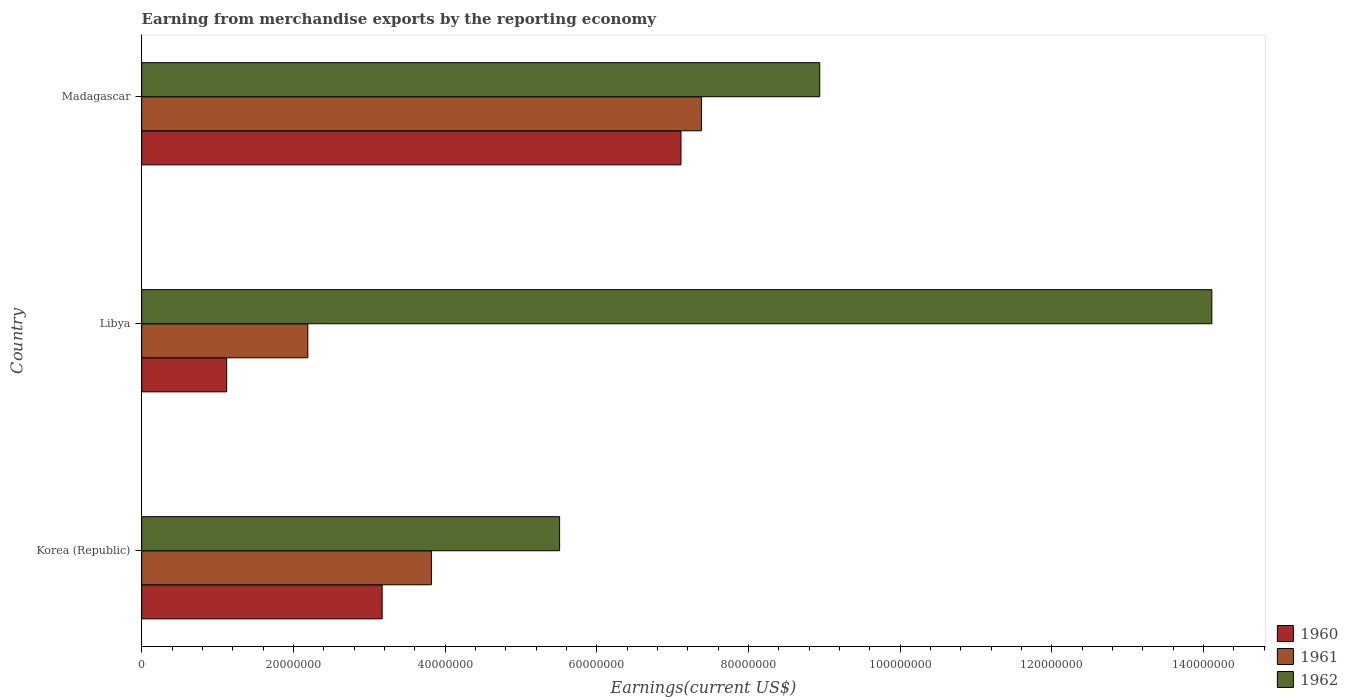How many different coloured bars are there?
Your answer should be compact. 3. How many groups of bars are there?
Keep it short and to the point. 3. Are the number of bars on each tick of the Y-axis equal?
Your response must be concise. Yes. How many bars are there on the 2nd tick from the top?
Offer a very short reply. 3. What is the label of the 2nd group of bars from the top?
Give a very brief answer. Libya. In how many cases, is the number of bars for a given country not equal to the number of legend labels?
Offer a very short reply. 0. What is the amount earned from merchandise exports in 1961 in Madagascar?
Provide a short and direct response. 7.38e+07. Across all countries, what is the maximum amount earned from merchandise exports in 1960?
Your answer should be compact. 7.11e+07. Across all countries, what is the minimum amount earned from merchandise exports in 1962?
Offer a very short reply. 5.51e+07. In which country was the amount earned from merchandise exports in 1961 maximum?
Your answer should be very brief. Madagascar. In which country was the amount earned from merchandise exports in 1962 minimum?
Your answer should be very brief. Korea (Republic). What is the total amount earned from merchandise exports in 1962 in the graph?
Your answer should be compact. 2.86e+08. What is the difference between the amount earned from merchandise exports in 1962 in Korea (Republic) and that in Madagascar?
Your response must be concise. -3.43e+07. What is the difference between the amount earned from merchandise exports in 1961 in Libya and the amount earned from merchandise exports in 1960 in Madagascar?
Make the answer very short. -4.92e+07. What is the average amount earned from merchandise exports in 1961 per country?
Give a very brief answer. 4.46e+07. What is the difference between the amount earned from merchandise exports in 1962 and amount earned from merchandise exports in 1961 in Madagascar?
Make the answer very short. 1.56e+07. In how many countries, is the amount earned from merchandise exports in 1960 greater than 132000000 US$?
Your answer should be compact. 0. What is the ratio of the amount earned from merchandise exports in 1962 in Korea (Republic) to that in Madagascar?
Give a very brief answer. 0.62. Is the difference between the amount earned from merchandise exports in 1962 in Korea (Republic) and Libya greater than the difference between the amount earned from merchandise exports in 1961 in Korea (Republic) and Libya?
Your answer should be very brief. No. What is the difference between the highest and the second highest amount earned from merchandise exports in 1961?
Offer a terse response. 3.56e+07. What is the difference between the highest and the lowest amount earned from merchandise exports in 1960?
Offer a very short reply. 5.99e+07. In how many countries, is the amount earned from merchandise exports in 1960 greater than the average amount earned from merchandise exports in 1960 taken over all countries?
Offer a very short reply. 1. Is it the case that in every country, the sum of the amount earned from merchandise exports in 1960 and amount earned from merchandise exports in 1961 is greater than the amount earned from merchandise exports in 1962?
Your answer should be compact. No. How many bars are there?
Make the answer very short. 9. Are all the bars in the graph horizontal?
Offer a terse response. Yes. Are the values on the major ticks of X-axis written in scientific E-notation?
Your response must be concise. No. Does the graph contain grids?
Ensure brevity in your answer.  No. Where does the legend appear in the graph?
Your answer should be very brief. Bottom right. What is the title of the graph?
Keep it short and to the point. Earning from merchandise exports by the reporting economy. Does "1990" appear as one of the legend labels in the graph?
Offer a very short reply. No. What is the label or title of the X-axis?
Offer a terse response. Earnings(current US$). What is the label or title of the Y-axis?
Provide a short and direct response. Country. What is the Earnings(current US$) in 1960 in Korea (Republic)?
Give a very brief answer. 3.17e+07. What is the Earnings(current US$) of 1961 in Korea (Republic)?
Make the answer very short. 3.82e+07. What is the Earnings(current US$) in 1962 in Korea (Republic)?
Offer a very short reply. 5.51e+07. What is the Earnings(current US$) in 1960 in Libya?
Your answer should be compact. 1.12e+07. What is the Earnings(current US$) of 1961 in Libya?
Provide a short and direct response. 2.19e+07. What is the Earnings(current US$) in 1962 in Libya?
Ensure brevity in your answer.  1.41e+08. What is the Earnings(current US$) in 1960 in Madagascar?
Make the answer very short. 7.11e+07. What is the Earnings(current US$) of 1961 in Madagascar?
Your response must be concise. 7.38e+07. What is the Earnings(current US$) in 1962 in Madagascar?
Give a very brief answer. 8.94e+07. Across all countries, what is the maximum Earnings(current US$) in 1960?
Make the answer very short. 7.11e+07. Across all countries, what is the maximum Earnings(current US$) in 1961?
Ensure brevity in your answer.  7.38e+07. Across all countries, what is the maximum Earnings(current US$) in 1962?
Your response must be concise. 1.41e+08. Across all countries, what is the minimum Earnings(current US$) of 1960?
Offer a terse response. 1.12e+07. Across all countries, what is the minimum Earnings(current US$) in 1961?
Give a very brief answer. 2.19e+07. Across all countries, what is the minimum Earnings(current US$) of 1962?
Your response must be concise. 5.51e+07. What is the total Earnings(current US$) in 1960 in the graph?
Offer a terse response. 1.14e+08. What is the total Earnings(current US$) in 1961 in the graph?
Offer a terse response. 1.34e+08. What is the total Earnings(current US$) of 1962 in the graph?
Keep it short and to the point. 2.86e+08. What is the difference between the Earnings(current US$) of 1960 in Korea (Republic) and that in Libya?
Give a very brief answer. 2.05e+07. What is the difference between the Earnings(current US$) of 1961 in Korea (Republic) and that in Libya?
Offer a very short reply. 1.63e+07. What is the difference between the Earnings(current US$) in 1962 in Korea (Republic) and that in Libya?
Offer a terse response. -8.60e+07. What is the difference between the Earnings(current US$) in 1960 in Korea (Republic) and that in Madagascar?
Ensure brevity in your answer.  -3.94e+07. What is the difference between the Earnings(current US$) of 1961 in Korea (Republic) and that in Madagascar?
Provide a short and direct response. -3.56e+07. What is the difference between the Earnings(current US$) in 1962 in Korea (Republic) and that in Madagascar?
Your response must be concise. -3.43e+07. What is the difference between the Earnings(current US$) in 1960 in Libya and that in Madagascar?
Offer a terse response. -5.99e+07. What is the difference between the Earnings(current US$) of 1961 in Libya and that in Madagascar?
Give a very brief answer. -5.19e+07. What is the difference between the Earnings(current US$) of 1962 in Libya and that in Madagascar?
Give a very brief answer. 5.17e+07. What is the difference between the Earnings(current US$) of 1960 in Korea (Republic) and the Earnings(current US$) of 1961 in Libya?
Your answer should be very brief. 9.80e+06. What is the difference between the Earnings(current US$) in 1960 in Korea (Republic) and the Earnings(current US$) in 1962 in Libya?
Keep it short and to the point. -1.09e+08. What is the difference between the Earnings(current US$) of 1961 in Korea (Republic) and the Earnings(current US$) of 1962 in Libya?
Give a very brief answer. -1.03e+08. What is the difference between the Earnings(current US$) of 1960 in Korea (Republic) and the Earnings(current US$) of 1961 in Madagascar?
Your response must be concise. -4.21e+07. What is the difference between the Earnings(current US$) in 1960 in Korea (Republic) and the Earnings(current US$) in 1962 in Madagascar?
Offer a very short reply. -5.77e+07. What is the difference between the Earnings(current US$) of 1961 in Korea (Republic) and the Earnings(current US$) of 1962 in Madagascar?
Offer a terse response. -5.12e+07. What is the difference between the Earnings(current US$) of 1960 in Libya and the Earnings(current US$) of 1961 in Madagascar?
Provide a short and direct response. -6.26e+07. What is the difference between the Earnings(current US$) of 1960 in Libya and the Earnings(current US$) of 1962 in Madagascar?
Provide a short and direct response. -7.82e+07. What is the difference between the Earnings(current US$) of 1961 in Libya and the Earnings(current US$) of 1962 in Madagascar?
Provide a succinct answer. -6.75e+07. What is the average Earnings(current US$) in 1960 per country?
Make the answer very short. 3.80e+07. What is the average Earnings(current US$) in 1961 per country?
Your response must be concise. 4.46e+07. What is the average Earnings(current US$) of 1962 per country?
Your answer should be very brief. 9.52e+07. What is the difference between the Earnings(current US$) in 1960 and Earnings(current US$) in 1961 in Korea (Republic)?
Make the answer very short. -6.50e+06. What is the difference between the Earnings(current US$) in 1960 and Earnings(current US$) in 1962 in Korea (Republic)?
Provide a succinct answer. -2.34e+07. What is the difference between the Earnings(current US$) in 1961 and Earnings(current US$) in 1962 in Korea (Republic)?
Offer a very short reply. -1.69e+07. What is the difference between the Earnings(current US$) in 1960 and Earnings(current US$) in 1961 in Libya?
Ensure brevity in your answer.  -1.07e+07. What is the difference between the Earnings(current US$) of 1960 and Earnings(current US$) of 1962 in Libya?
Offer a very short reply. -1.30e+08. What is the difference between the Earnings(current US$) in 1961 and Earnings(current US$) in 1962 in Libya?
Offer a terse response. -1.19e+08. What is the difference between the Earnings(current US$) in 1960 and Earnings(current US$) in 1961 in Madagascar?
Provide a short and direct response. -2.70e+06. What is the difference between the Earnings(current US$) of 1960 and Earnings(current US$) of 1962 in Madagascar?
Offer a terse response. -1.83e+07. What is the difference between the Earnings(current US$) in 1961 and Earnings(current US$) in 1962 in Madagascar?
Offer a very short reply. -1.56e+07. What is the ratio of the Earnings(current US$) of 1960 in Korea (Republic) to that in Libya?
Offer a very short reply. 2.83. What is the ratio of the Earnings(current US$) of 1961 in Korea (Republic) to that in Libya?
Your answer should be compact. 1.74. What is the ratio of the Earnings(current US$) in 1962 in Korea (Republic) to that in Libya?
Offer a very short reply. 0.39. What is the ratio of the Earnings(current US$) in 1960 in Korea (Republic) to that in Madagascar?
Offer a terse response. 0.45. What is the ratio of the Earnings(current US$) of 1961 in Korea (Republic) to that in Madagascar?
Offer a terse response. 0.52. What is the ratio of the Earnings(current US$) of 1962 in Korea (Republic) to that in Madagascar?
Make the answer very short. 0.62. What is the ratio of the Earnings(current US$) in 1960 in Libya to that in Madagascar?
Provide a short and direct response. 0.16. What is the ratio of the Earnings(current US$) in 1961 in Libya to that in Madagascar?
Ensure brevity in your answer.  0.3. What is the ratio of the Earnings(current US$) in 1962 in Libya to that in Madagascar?
Offer a very short reply. 1.58. What is the difference between the highest and the second highest Earnings(current US$) of 1960?
Offer a terse response. 3.94e+07. What is the difference between the highest and the second highest Earnings(current US$) of 1961?
Give a very brief answer. 3.56e+07. What is the difference between the highest and the second highest Earnings(current US$) of 1962?
Give a very brief answer. 5.17e+07. What is the difference between the highest and the lowest Earnings(current US$) in 1960?
Offer a very short reply. 5.99e+07. What is the difference between the highest and the lowest Earnings(current US$) of 1961?
Provide a succinct answer. 5.19e+07. What is the difference between the highest and the lowest Earnings(current US$) of 1962?
Make the answer very short. 8.60e+07. 